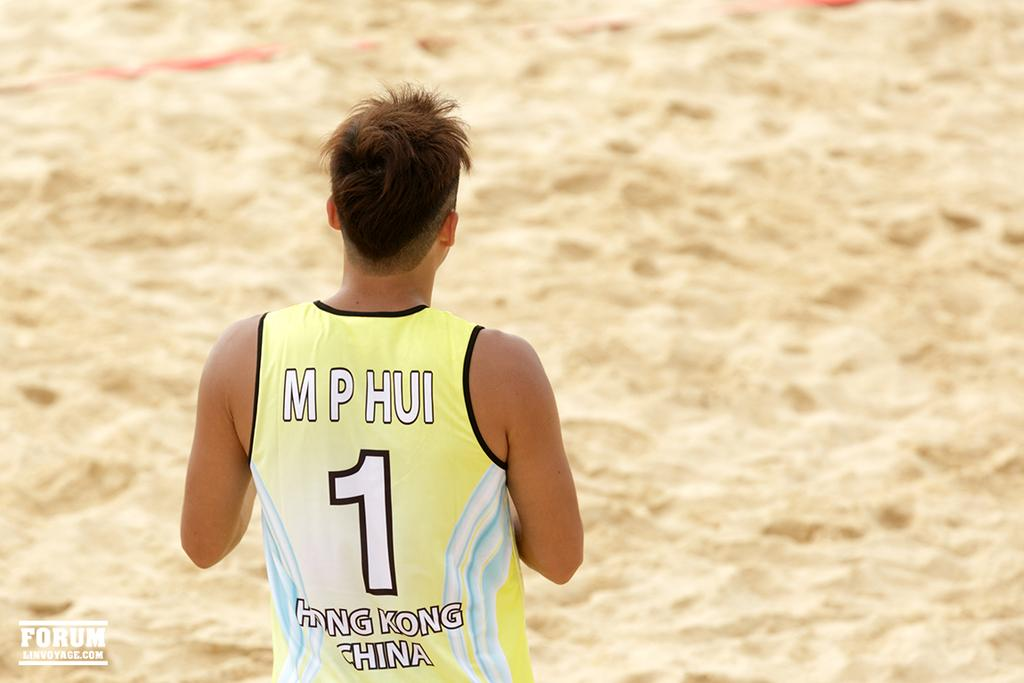<image>
Render a clear and concise summary of the photo. M P Hui from Hong Kong, China is wearing a yellow tank top with the number 1. 